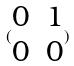<formula> <loc_0><loc_0><loc_500><loc_500>( \begin{matrix} 0 & 1 \\ 0 & 0 \end{matrix} )</formula> 